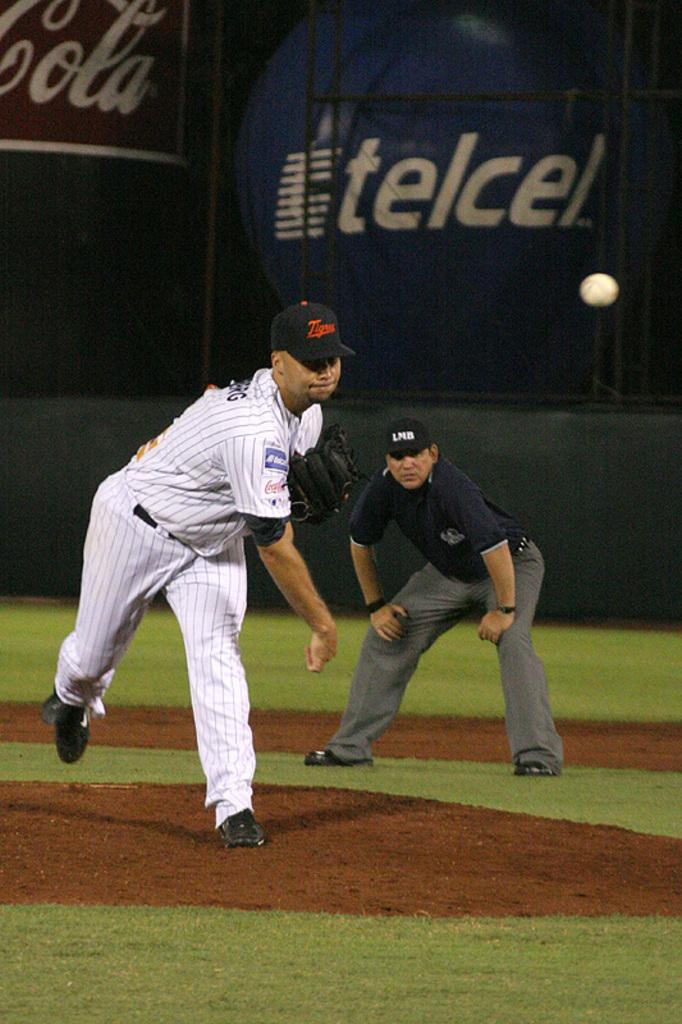<image>
Render a clear and concise summary of the photo. A baseball player has just thrown the ball in a stadium that says telcel. 